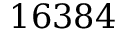Convert formula to latex. <formula><loc_0><loc_0><loc_500><loc_500>1 6 3 8 4</formula> 